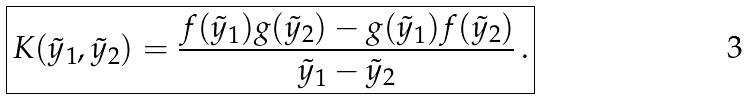Convert formula to latex. <formula><loc_0><loc_0><loc_500><loc_500>\boxed { K ( \tilde { y } _ { 1 } , \tilde { y } _ { 2 } ) = \frac { f ( \tilde { y } _ { 1 } ) g ( \tilde { y } _ { 2 } ) - g ( \tilde { y } _ { 1 } ) f ( \tilde { y } _ { 2 } ) } { \tilde { y } _ { 1 } - \tilde { y } _ { 2 } } \, . }</formula> 